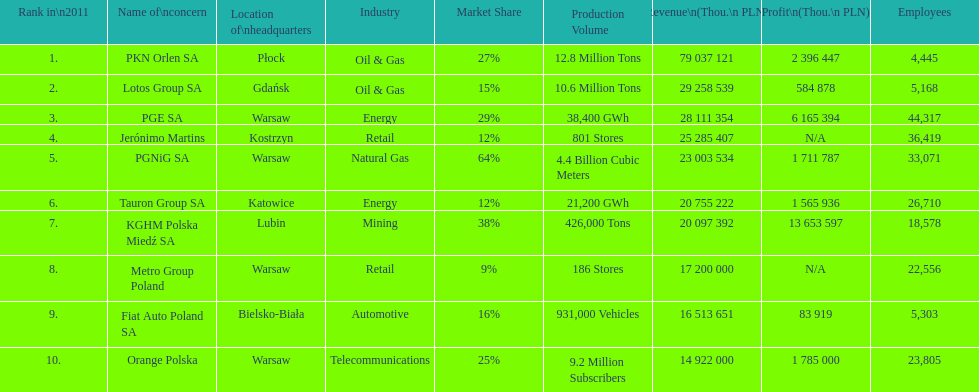What is the number of employees who work for pgnig sa? 33,071. 